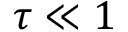Convert formula to latex. <formula><loc_0><loc_0><loc_500><loc_500>\tau \ll 1</formula> 